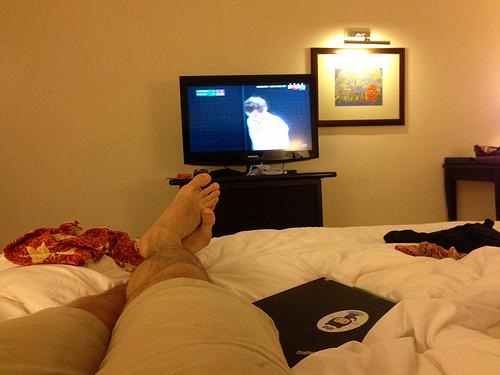Question: what is the man doing?
Choices:
A. Eating.
B. Watching TV.
C. Sleeping.
D. Running.
Answer with the letter. Answer: B Question: how many people are there?
Choices:
A. One.
B. Two.
C. Three.
D. Four.
Answer with the letter. Answer: A Question: how do the man's feet look?
Choices:
A. He has boots on.
B. He has sneakers on.
C. He has slippers on.
D. He is barefoot.
Answer with the letter. Answer: D 